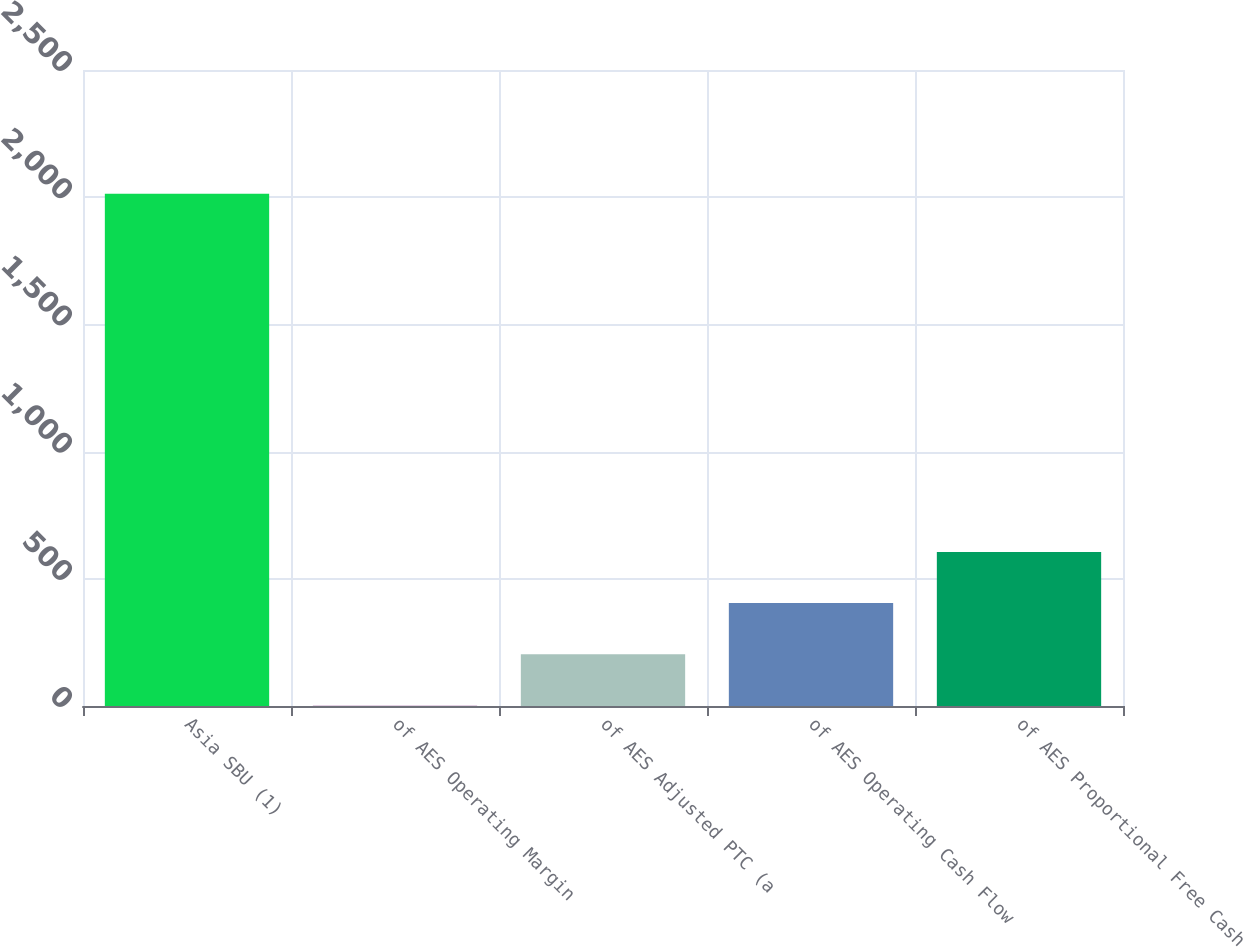Convert chart. <chart><loc_0><loc_0><loc_500><loc_500><bar_chart><fcel>Asia SBU (1)<fcel>of AES Operating Margin<fcel>of AES Adjusted PTC (a<fcel>of AES Operating Cash Flow<fcel>of AES Proportional Free Cash<nl><fcel>2014<fcel>2<fcel>203.2<fcel>404.4<fcel>605.6<nl></chart> 